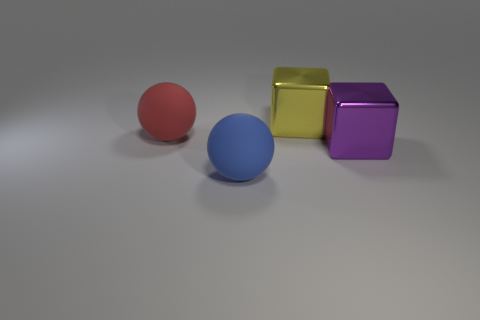Add 3 purple blocks. How many objects exist? 7 Add 2 red things. How many red things exist? 3 Subtract 0 green spheres. How many objects are left? 4 Subtract all red matte balls. Subtract all red matte balls. How many objects are left? 2 Add 1 yellow cubes. How many yellow cubes are left? 2 